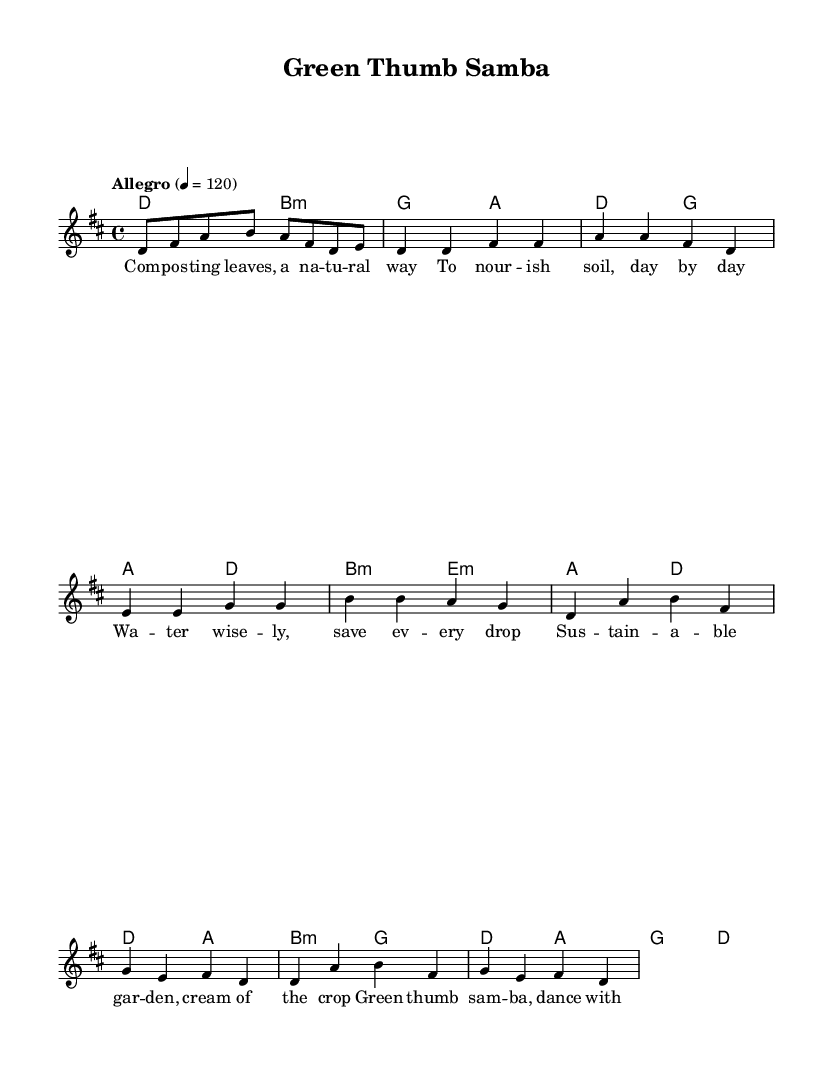What is the key signature of this music? The key signature is D major, which has two sharps (F# and C#). The presence of the F# and C# in the melody indicates that the music is in D major.
Answer: D major What is the time signature of this music? The time signature is 4/4, as indicated at the beginning of the score. This means there are four beats in each measure and a quarter note gets one beat.
Answer: 4/4 What tempo marking is indicated for this piece? The tempo marking is "Allegro," which suggests a fast and lively pace. The specific metronome marking of 4 = 120 indicates that the quarter note should be played at 120 beats per minute.
Answer: Allegro How many measures are there in the verse section? The verse section consists of four measures, as can be counted from the notation provided in the melody and harmonies. Each set of four quarter notes corresponds to one measure in 4/4 time.
Answer: 4 What is the main theme of the lyrics expressed in the chorus? The chorus emphasizes eco-friendliness and sustainable gardening practices, mentioning the importance of organic methods and dancing with the plants. This reflects a celebration of nature and care for the environment.
Answer: Eco-friendly rhythm What is the melodic range of the lead voice in this piece? The melodic range within the lead voice is from D to B, as indicated by the highest and lowest pitches in the melody. This range allows for a bright and vibrant vocal performance characteristic of Latin pop.
Answer: D to B 